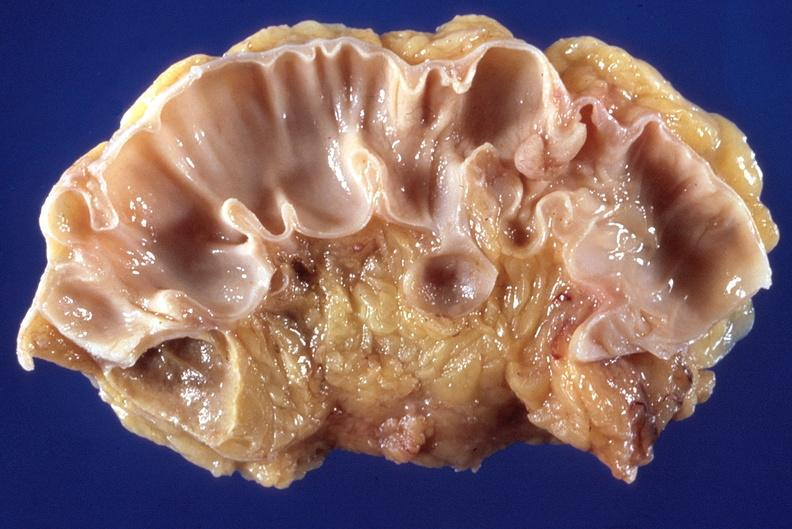what does this image show?
Answer the question using a single word or phrase. Sigmoid colon 